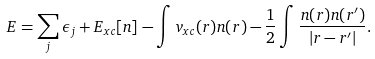<formula> <loc_0><loc_0><loc_500><loc_500>E = \sum _ { j } \epsilon _ { j } + E _ { x c } [ n ] - \int v _ { x c } ( r ) n ( r ) - \frac { 1 } { 2 } \int \frac { n ( r ) n ( r ^ { \prime } ) } { | r - r ^ { \prime } | } .</formula> 